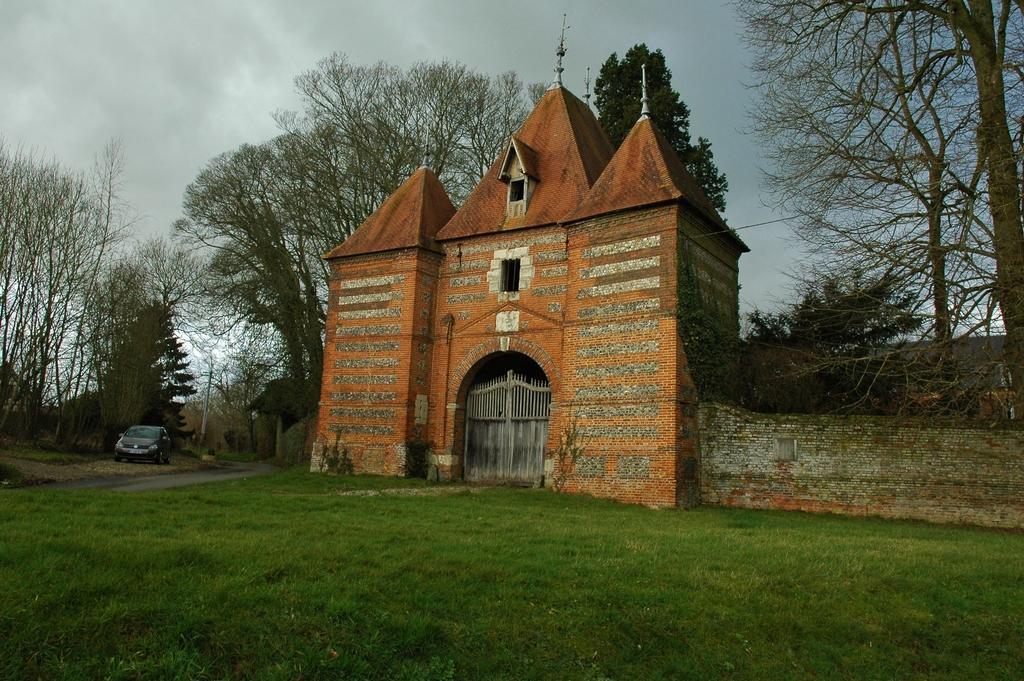Can you describe this image briefly? In this picture we can observe some grass on the ground. There is a building. We can observe a grey color gate. On the left side there is a car parked on the ground. In the background there are trees and a sky with some clouds. 